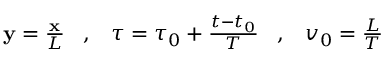<formula> <loc_0><loc_0><loc_500><loc_500>\begin{array} { r } { { \mathbf y } = \frac { \mathbf x } { L } \, , \, \tau = \tau _ { 0 } + \frac { t - t _ { 0 } } { T } \, , \, v _ { 0 } = \frac { L } { T } } \end{array}</formula> 